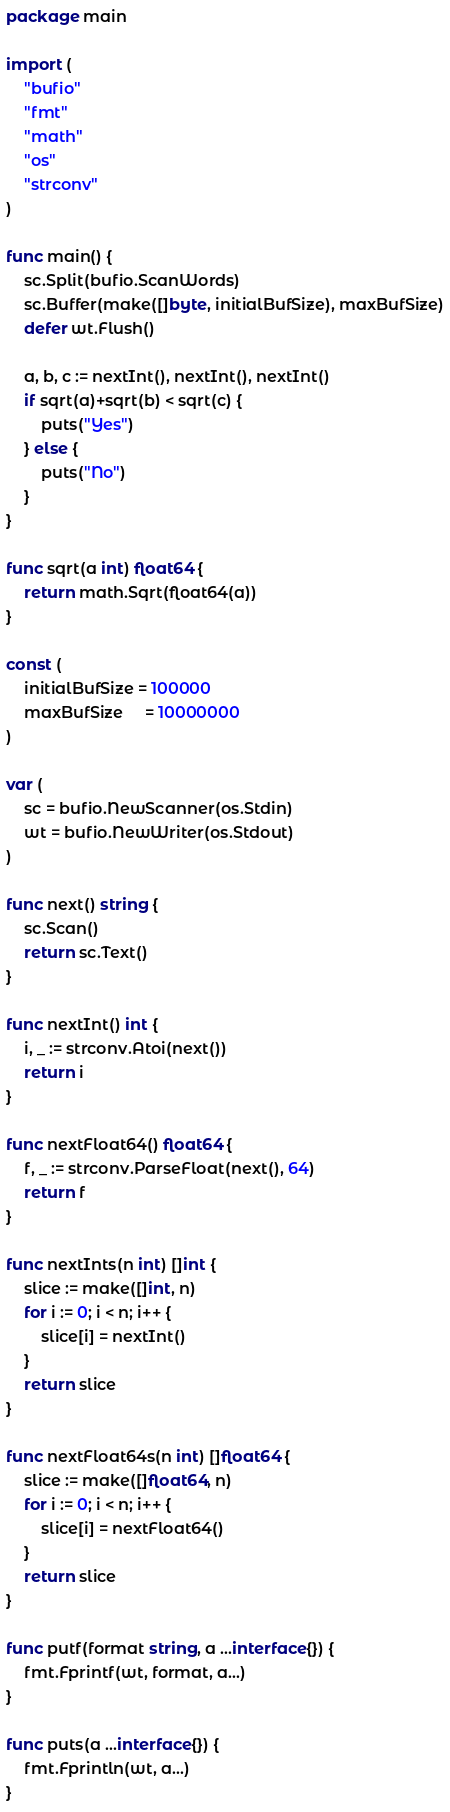Convert code to text. <code><loc_0><loc_0><loc_500><loc_500><_Go_>package main

import (
	"bufio"
	"fmt"
	"math"
	"os"
	"strconv"
)

func main() {
	sc.Split(bufio.ScanWords)
	sc.Buffer(make([]byte, initialBufSize), maxBufSize)
	defer wt.Flush()

	a, b, c := nextInt(), nextInt(), nextInt()
	if sqrt(a)+sqrt(b) < sqrt(c) {
		puts("Yes")
	} else {
		puts("No")
	}
}

func sqrt(a int) float64 {
	return math.Sqrt(float64(a))
}

const (
	initialBufSize = 100000
	maxBufSize     = 10000000
)

var (
	sc = bufio.NewScanner(os.Stdin)
	wt = bufio.NewWriter(os.Stdout)
)

func next() string {
	sc.Scan()
	return sc.Text()
}

func nextInt() int {
	i, _ := strconv.Atoi(next())
	return i
}

func nextFloat64() float64 {
	f, _ := strconv.ParseFloat(next(), 64)
	return f
}

func nextInts(n int) []int {
	slice := make([]int, n)
	for i := 0; i < n; i++ {
		slice[i] = nextInt()
	}
	return slice
}

func nextFloat64s(n int) []float64 {
	slice := make([]float64, n)
	for i := 0; i < n; i++ {
		slice[i] = nextFloat64()
	}
	return slice
}

func putf(format string, a ...interface{}) {
	fmt.Fprintf(wt, format, a...)
}

func puts(a ...interface{}) {
	fmt.Fprintln(wt, a...)
}
</code> 